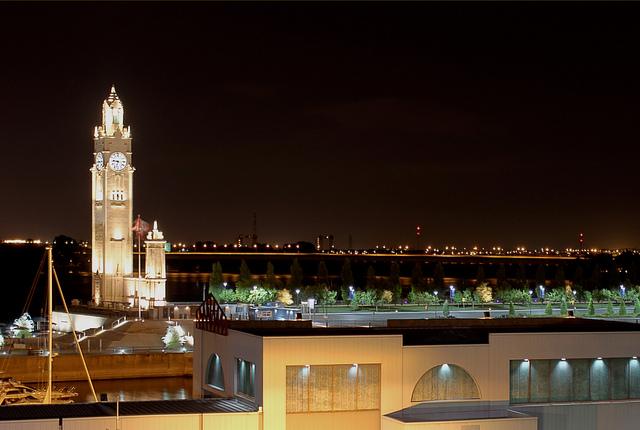In the foreground are the lights shining up or down?
Be succinct. Down. Is it morning or evening?
Write a very short answer. Evening. Is there a clock on the tower?
Keep it brief. Yes. Is there a body of water here?
Answer briefly. Yes. How many lights in the picture?
Write a very short answer. 20. 